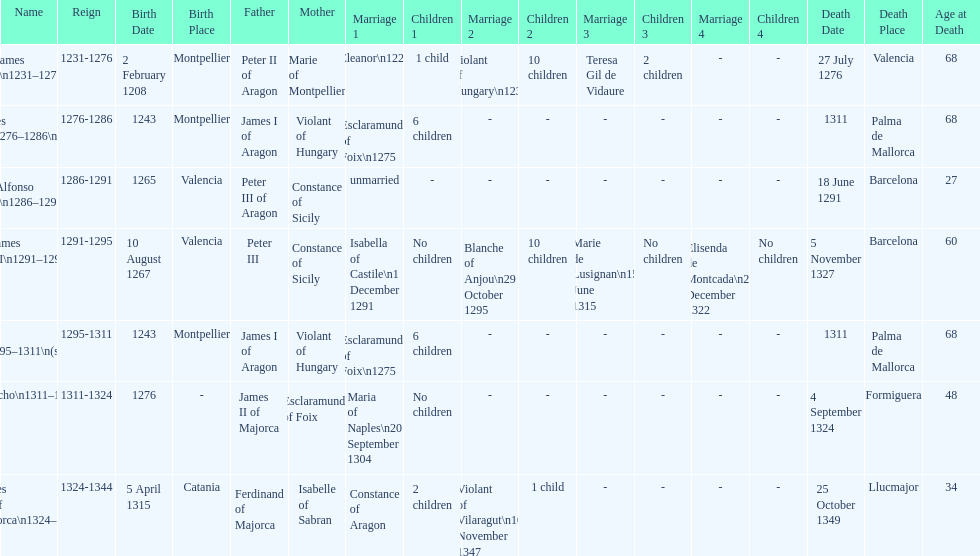How many total marriages did james i have? 3. 